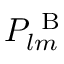<formula> <loc_0><loc_0><loc_500><loc_500>P _ { l m } ^ { B }</formula> 